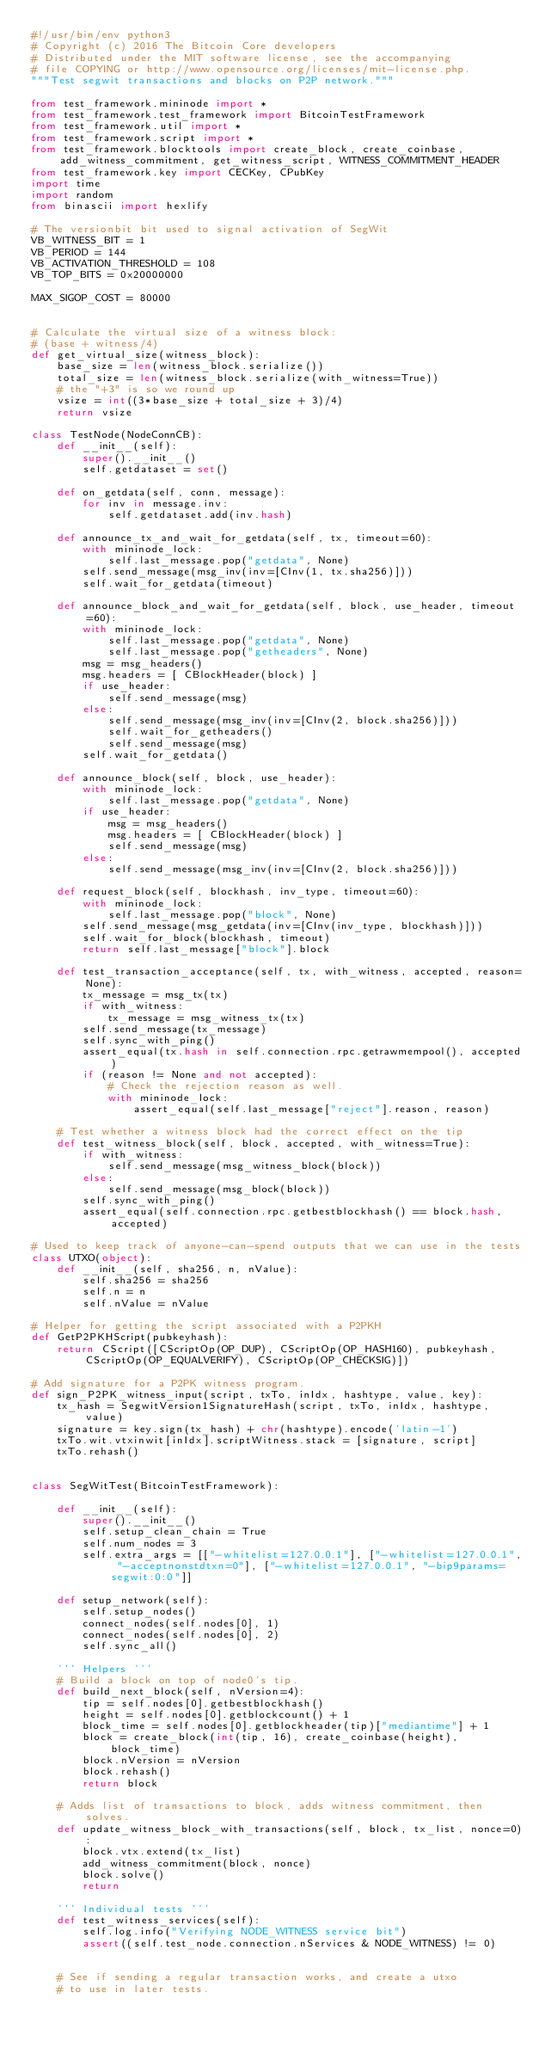<code> <loc_0><loc_0><loc_500><loc_500><_Python_>#!/usr/bin/env python3
# Copyright (c) 2016 The Bitcoin Core developers
# Distributed under the MIT software license, see the accompanying
# file COPYING or http://www.opensource.org/licenses/mit-license.php.
"""Test segwit transactions and blocks on P2P network."""

from test_framework.mininode import *
from test_framework.test_framework import BitcoinTestFramework
from test_framework.util import *
from test_framework.script import *
from test_framework.blocktools import create_block, create_coinbase, add_witness_commitment, get_witness_script, WITNESS_COMMITMENT_HEADER
from test_framework.key import CECKey, CPubKey
import time
import random
from binascii import hexlify

# The versionbit bit used to signal activation of SegWit
VB_WITNESS_BIT = 1
VB_PERIOD = 144
VB_ACTIVATION_THRESHOLD = 108
VB_TOP_BITS = 0x20000000

MAX_SIGOP_COST = 80000


# Calculate the virtual size of a witness block:
# (base + witness/4)
def get_virtual_size(witness_block):
    base_size = len(witness_block.serialize())
    total_size = len(witness_block.serialize(with_witness=True))
    # the "+3" is so we round up
    vsize = int((3*base_size + total_size + 3)/4)
    return vsize

class TestNode(NodeConnCB):
    def __init__(self):
        super().__init__()
        self.getdataset = set()

    def on_getdata(self, conn, message):
        for inv in message.inv:
            self.getdataset.add(inv.hash)

    def announce_tx_and_wait_for_getdata(self, tx, timeout=60):
        with mininode_lock:
            self.last_message.pop("getdata", None)
        self.send_message(msg_inv(inv=[CInv(1, tx.sha256)]))
        self.wait_for_getdata(timeout)

    def announce_block_and_wait_for_getdata(self, block, use_header, timeout=60):
        with mininode_lock:
            self.last_message.pop("getdata", None)
            self.last_message.pop("getheaders", None)
        msg = msg_headers()
        msg.headers = [ CBlockHeader(block) ]
        if use_header:
            self.send_message(msg)
        else:
            self.send_message(msg_inv(inv=[CInv(2, block.sha256)]))
            self.wait_for_getheaders()
            self.send_message(msg)
        self.wait_for_getdata()

    def announce_block(self, block, use_header):
        with mininode_lock:
            self.last_message.pop("getdata", None)
        if use_header:
            msg = msg_headers()
            msg.headers = [ CBlockHeader(block) ]
            self.send_message(msg)
        else:
            self.send_message(msg_inv(inv=[CInv(2, block.sha256)]))

    def request_block(self, blockhash, inv_type, timeout=60):
        with mininode_lock:
            self.last_message.pop("block", None)
        self.send_message(msg_getdata(inv=[CInv(inv_type, blockhash)]))
        self.wait_for_block(blockhash, timeout)
        return self.last_message["block"].block

    def test_transaction_acceptance(self, tx, with_witness, accepted, reason=None):
        tx_message = msg_tx(tx)
        if with_witness:
            tx_message = msg_witness_tx(tx)
        self.send_message(tx_message)
        self.sync_with_ping()
        assert_equal(tx.hash in self.connection.rpc.getrawmempool(), accepted)
        if (reason != None and not accepted):
            # Check the rejection reason as well.
            with mininode_lock:
                assert_equal(self.last_message["reject"].reason, reason)

    # Test whether a witness block had the correct effect on the tip
    def test_witness_block(self, block, accepted, with_witness=True):
        if with_witness:
            self.send_message(msg_witness_block(block))
        else:
            self.send_message(msg_block(block))
        self.sync_with_ping()
        assert_equal(self.connection.rpc.getbestblockhash() == block.hash, accepted)

# Used to keep track of anyone-can-spend outputs that we can use in the tests
class UTXO(object):
    def __init__(self, sha256, n, nValue):
        self.sha256 = sha256
        self.n = n
        self.nValue = nValue

# Helper for getting the script associated with a P2PKH
def GetP2PKHScript(pubkeyhash):
    return CScript([CScriptOp(OP_DUP), CScriptOp(OP_HASH160), pubkeyhash, CScriptOp(OP_EQUALVERIFY), CScriptOp(OP_CHECKSIG)])

# Add signature for a P2PK witness program.
def sign_P2PK_witness_input(script, txTo, inIdx, hashtype, value, key):
    tx_hash = SegwitVersion1SignatureHash(script, txTo, inIdx, hashtype, value)
    signature = key.sign(tx_hash) + chr(hashtype).encode('latin-1')
    txTo.wit.vtxinwit[inIdx].scriptWitness.stack = [signature, script]
    txTo.rehash()


class SegWitTest(BitcoinTestFramework):

    def __init__(self):
        super().__init__()
        self.setup_clean_chain = True
        self.num_nodes = 3
        self.extra_args = [["-whitelist=127.0.0.1"], ["-whitelist=127.0.0.1", "-acceptnonstdtxn=0"], ["-whitelist=127.0.0.1", "-bip9params=segwit:0:0"]]

    def setup_network(self):
        self.setup_nodes()
        connect_nodes(self.nodes[0], 1)
        connect_nodes(self.nodes[0], 2)
        self.sync_all()

    ''' Helpers '''
    # Build a block on top of node0's tip.
    def build_next_block(self, nVersion=4):
        tip = self.nodes[0].getbestblockhash()
        height = self.nodes[0].getblockcount() + 1
        block_time = self.nodes[0].getblockheader(tip)["mediantime"] + 1
        block = create_block(int(tip, 16), create_coinbase(height), block_time)
        block.nVersion = nVersion
        block.rehash()
        return block

    # Adds list of transactions to block, adds witness commitment, then solves.
    def update_witness_block_with_transactions(self, block, tx_list, nonce=0):
        block.vtx.extend(tx_list)
        add_witness_commitment(block, nonce)
        block.solve()
        return

    ''' Individual tests '''
    def test_witness_services(self):
        self.log.info("Verifying NODE_WITNESS service bit")
        assert((self.test_node.connection.nServices & NODE_WITNESS) != 0)


    # See if sending a regular transaction works, and create a utxo
    # to use in later tests.</code> 